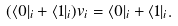<formula> <loc_0><loc_0><loc_500><loc_500>( \langle 0 | _ { i } + \langle 1 | _ { i } ) v _ { i } = \langle 0 | _ { i } + \langle 1 | _ { i } .</formula> 